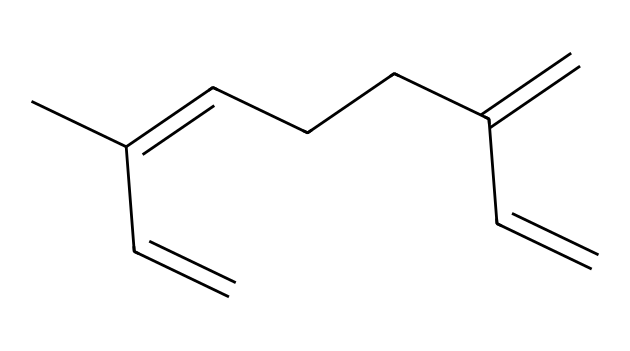How many carbon atoms are in myrcene? Counting the "C" symbols in the SMILES representation reveals there are 10 carbon atoms in total.
Answer: 10 What type of functional groups are present in myrcene? The structure mostly consists of alkenes, indicated by the presence of double bonds (=). There are no functional groups like alcohols or ketones present.
Answer: alkenes What is the basic molecular formula of myrcene? By identifying the number of carbon (C) and hydrogen (H) atoms from the structure, the molecular formula can be derived as C10H16.
Answer: C10H16 How many double bonds does myrcene contain? The SMILES representation shows four instances of double bonds (=), indicating there are four double bonds in the structure.
Answer: 4 What type of aroma does myrcene contribute to in mangoes? Myrcene is known to have a sweet, fruity aroma that is reminiscent of mangoes and contributes favorably to the scent of several plants and foods.
Answer: sweet, fruity How does the structure of myrcene relate to its aromatic properties? The presence of consecutive double bonds allows for a more flexible carbon chain, which can enhance the volatility and aroma of the compound, making it more fragrant.
Answer: enhances fragrance Is myrcene a cyclic or acyclic compound? Reviewing the SMILES, there are no cycles in the structure, confirming that myrcene is an acyclic compound.
Answer: acyclic 